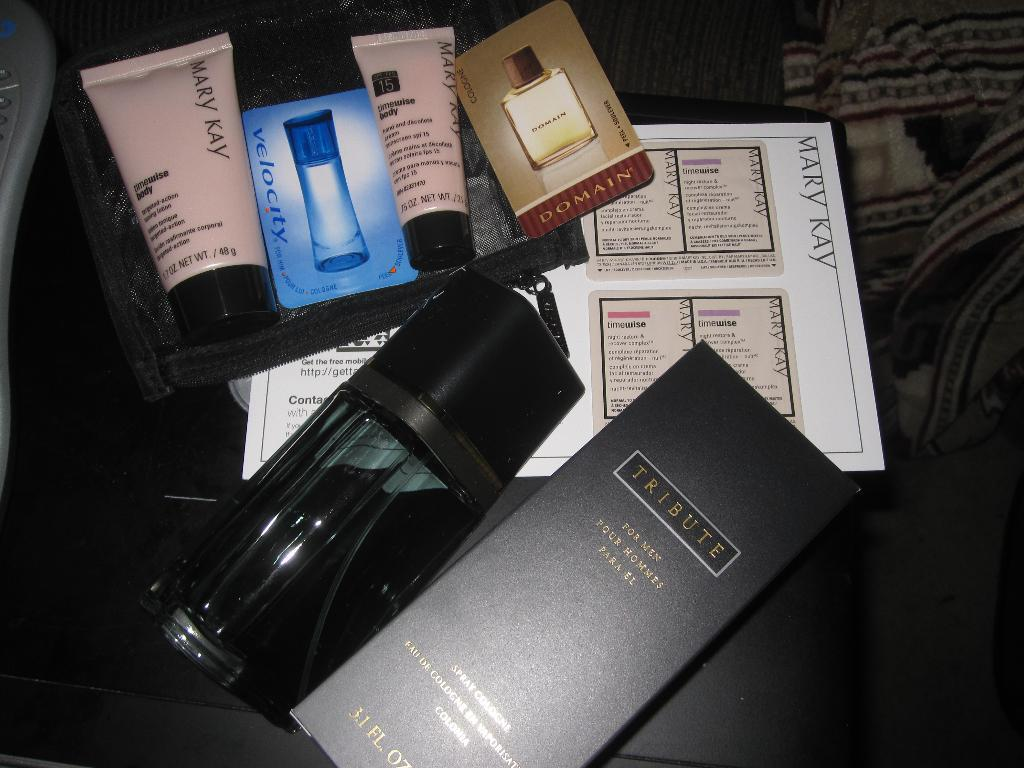Provide a one-sentence caption for the provided image. Box with a Tribute label and a Mary Kay logo on a pink bottle. 